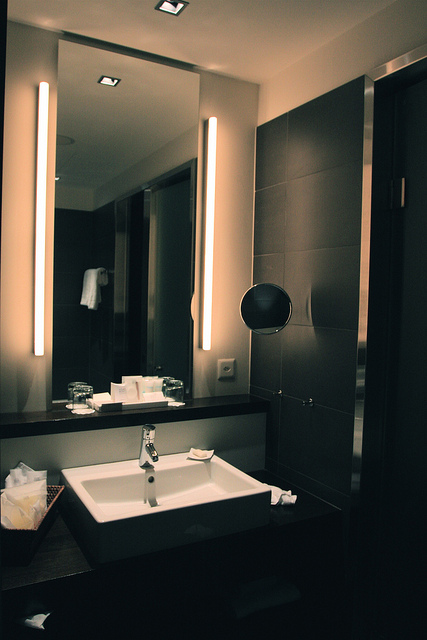Is there a bathtub or a shower visible in the image? No, neither a bathtub nor a shower is visible in the image. The photo focuses mainly on the sink area and the surrounding fixtures. 